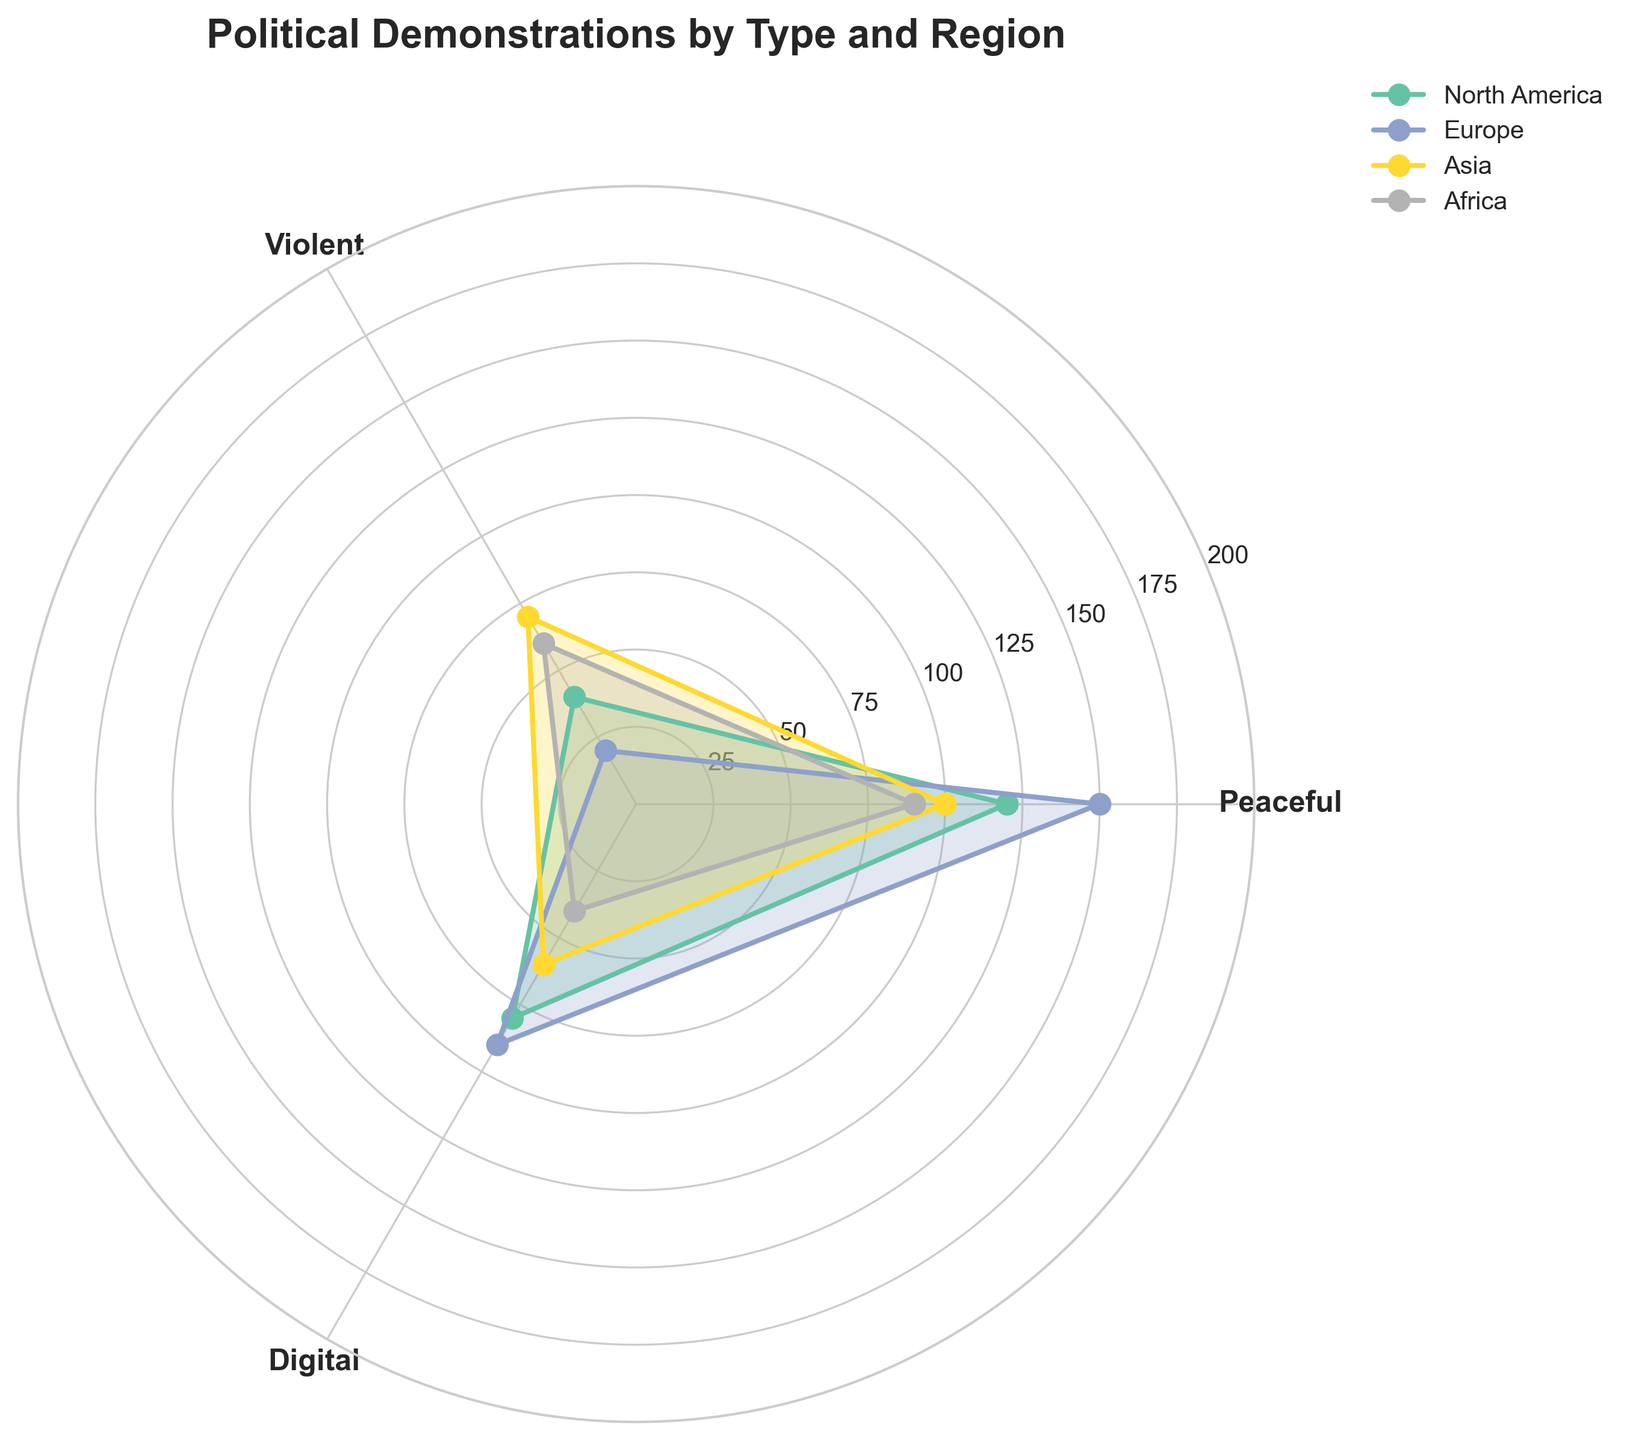What type of political demonstration has the highest frequency in North America? Look at the data points in the figure for North America and identify which type of demonstration has the longest radius in the rose chart. The peaceful demonstration segment has the longest radius.
Answer: Peaceful Which region has the highest frequency of digital demonstrations? Compare the radial lengths of the digital demonstrations across all regions. The region with the longest radial length for digital demonstrations is Europe.
Answer: Europe What is the difference in frequency between violent and peaceful demonstrations in Asia? Identify the radial length corresponding to violent and peaceful demonstrations in Asia and subtract the value of violent from peaceful. Violent demonstrations have a frequency of 70 and peaceful have 100, so the difference is 100 - 70.
Answer: 30 How does the frequency of peaceful demonstrations in Africa compare to that in Europe? Compare the radial lengths of peaceful demonstrations in Africa and Europe. Peaceful demonstrations have a frequency of 90 in Africa and 150 in Europe, so Europe has more.
Answer: Europe has more Which type of demonstration has the least variation in frequency across the regions? Observe the radial lengths of all three types of demonstrations across the different regions and see which one has the least difference between the longest and shortest radii. Digital demonstrations vary less compared to peaceful and violent ones.
Answer: Digital What is the average frequency of political demonstrations in Europe? Add the frequencies of all three types in Europe and divide by the number of types. (150 for peaceful + 20 for violent + 90 for digital) / 3 = 86.7
Answer: 86.7 In which region do violent demonstrations have the highest frequency? Compare the radial lengths of violent demonstrations across all regions and identify the region with the longest radius. Asia has the longest radial length with a frequency of 70.
Answer: Asia What is the total frequency of peaceful demonstrations across all regions? Add the frequencies of peaceful demonstrations from all regions: 120 (North America) + 150 (Europe) + 100 (Asia) + 90 (Africa) = 460.
Answer: 460 How do the frequencies of violent and digital demonstrations compare in North America? Compare the radial lengths of violent and digital demonstrations in North America. North America has 40 for violent and 80 for digital, so digital is higher.
Answer: Digital is higher What is the overall frequency of political demonstrations in Asia? Sum the frequencies of all types of demonstrations in Asia. Peaceful (100) + Violent (70) + Digital (60) = 230
Answer: 230 